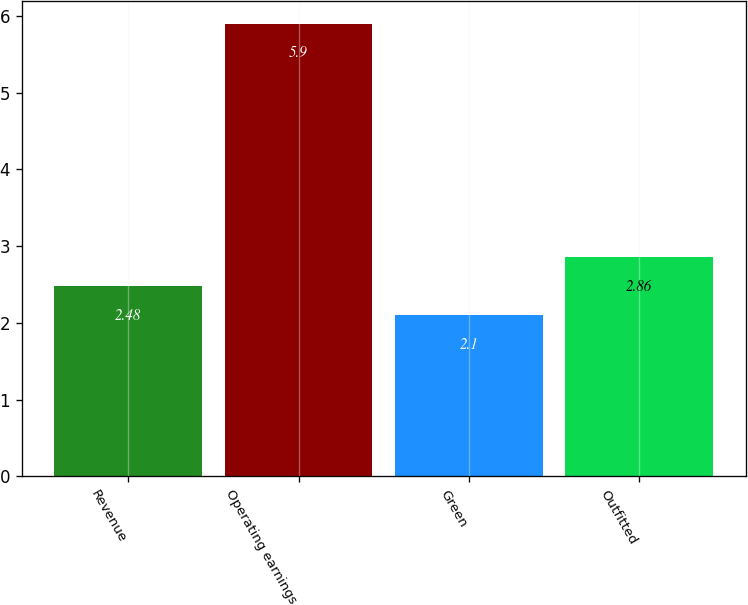Convert chart to OTSL. <chart><loc_0><loc_0><loc_500><loc_500><bar_chart><fcel>Revenue<fcel>Operating earnings<fcel>Green<fcel>Outfitted<nl><fcel>2.48<fcel>5.9<fcel>2.1<fcel>2.86<nl></chart> 